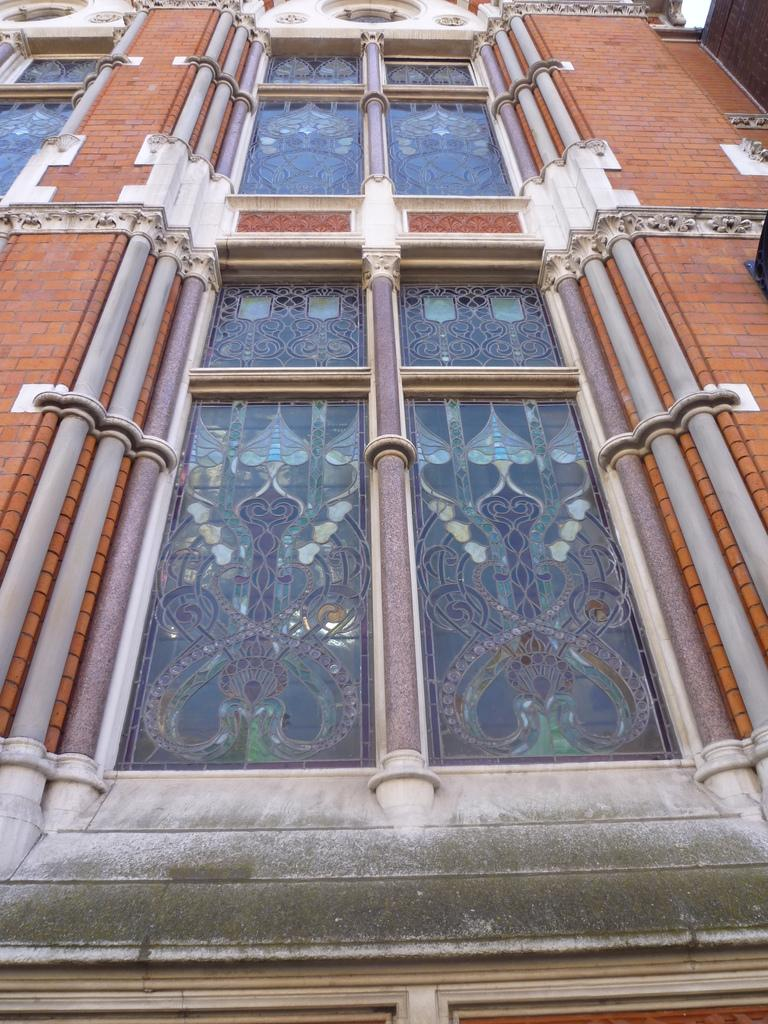What is the main structure visible in the image? There is a building in the image. What feature can be seen on the building? There are windows in the building. What type of oil is being used to lubricate the crook's class in the image? There is no oil, crook, or class present in the image; it only features a building with windows. 